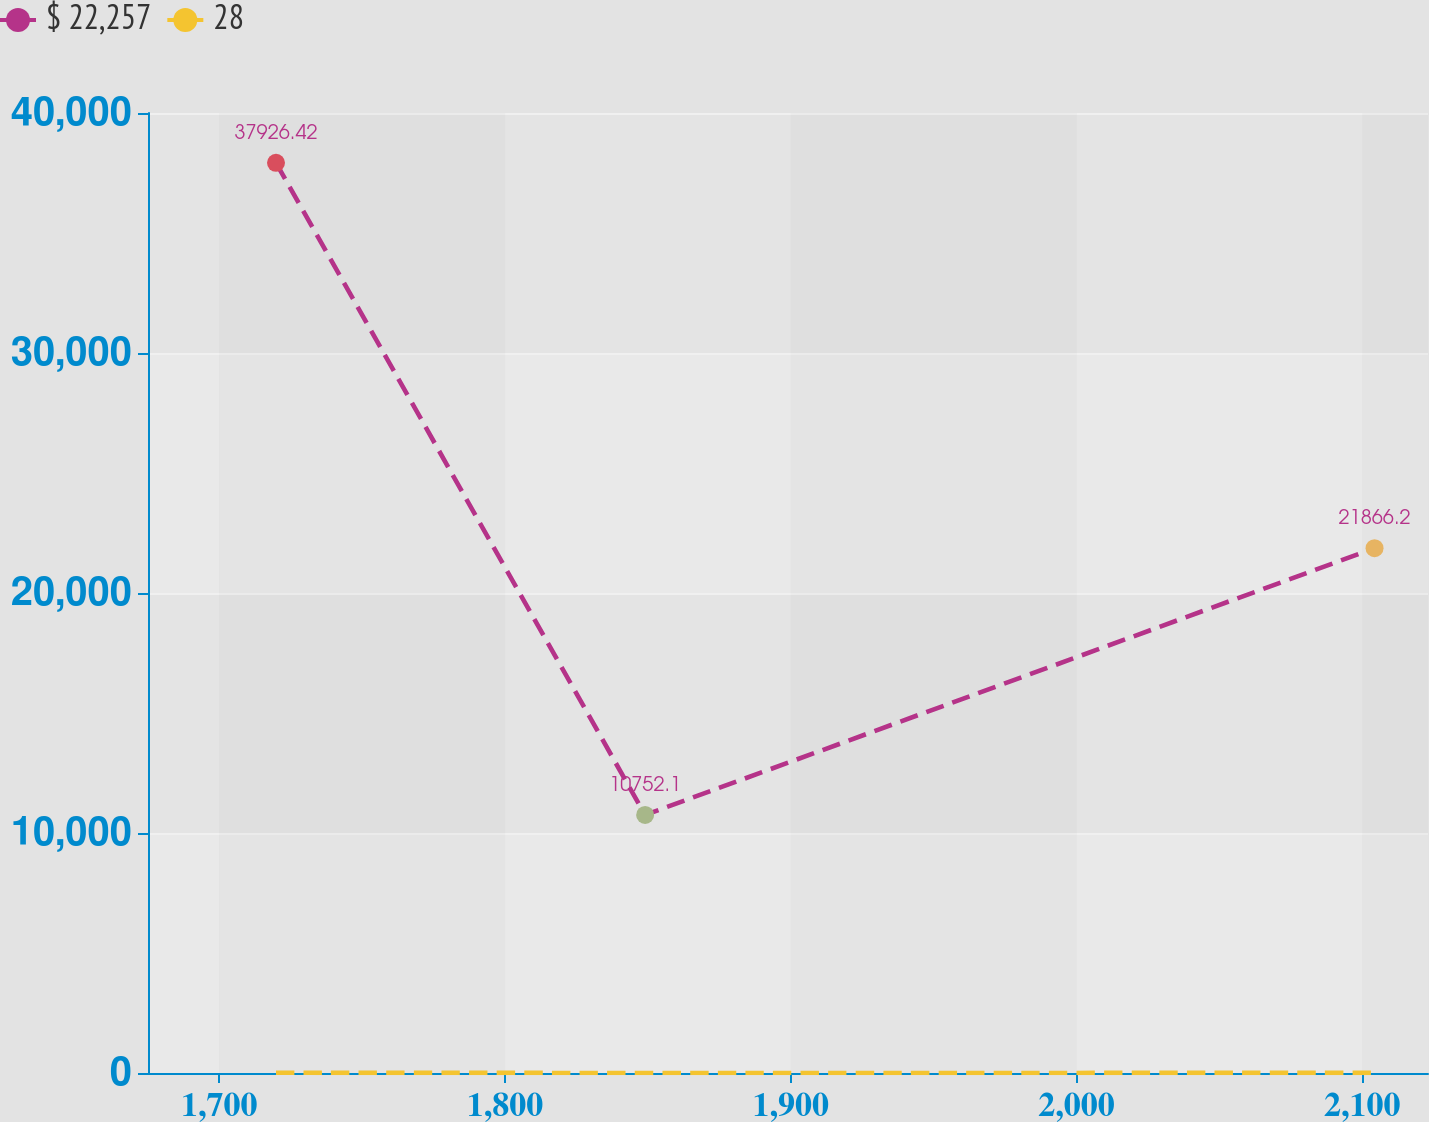Convert chart. <chart><loc_0><loc_0><loc_500><loc_500><line_chart><ecel><fcel>$ 22,257<fcel>28<nl><fcel>1719.84<fcel>37926.4<fcel>8.49<nl><fcel>1849.02<fcel>10752.1<fcel>2.64<nl><fcel>2104.28<fcel>21866.2<fcel>3.91<nl><fcel>2167.78<fcel>29723.5<fcel>15.38<nl></chart> 